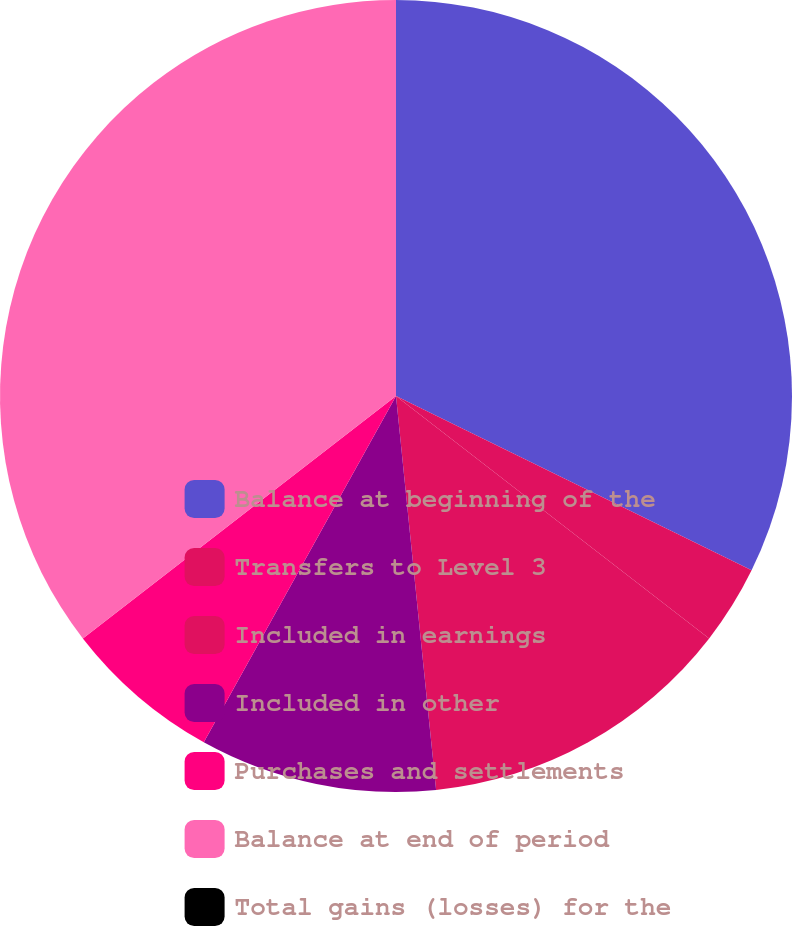Convert chart to OTSL. <chart><loc_0><loc_0><loc_500><loc_500><pie_chart><fcel>Balance at beginning of the<fcel>Transfers to Level 3<fcel>Included in earnings<fcel>Included in other<fcel>Purchases and settlements<fcel>Balance at end of period<fcel>Total gains (losses) for the<nl><fcel>32.25%<fcel>3.23%<fcel>12.9%<fcel>9.68%<fcel>6.45%<fcel>35.48%<fcel>0.0%<nl></chart> 